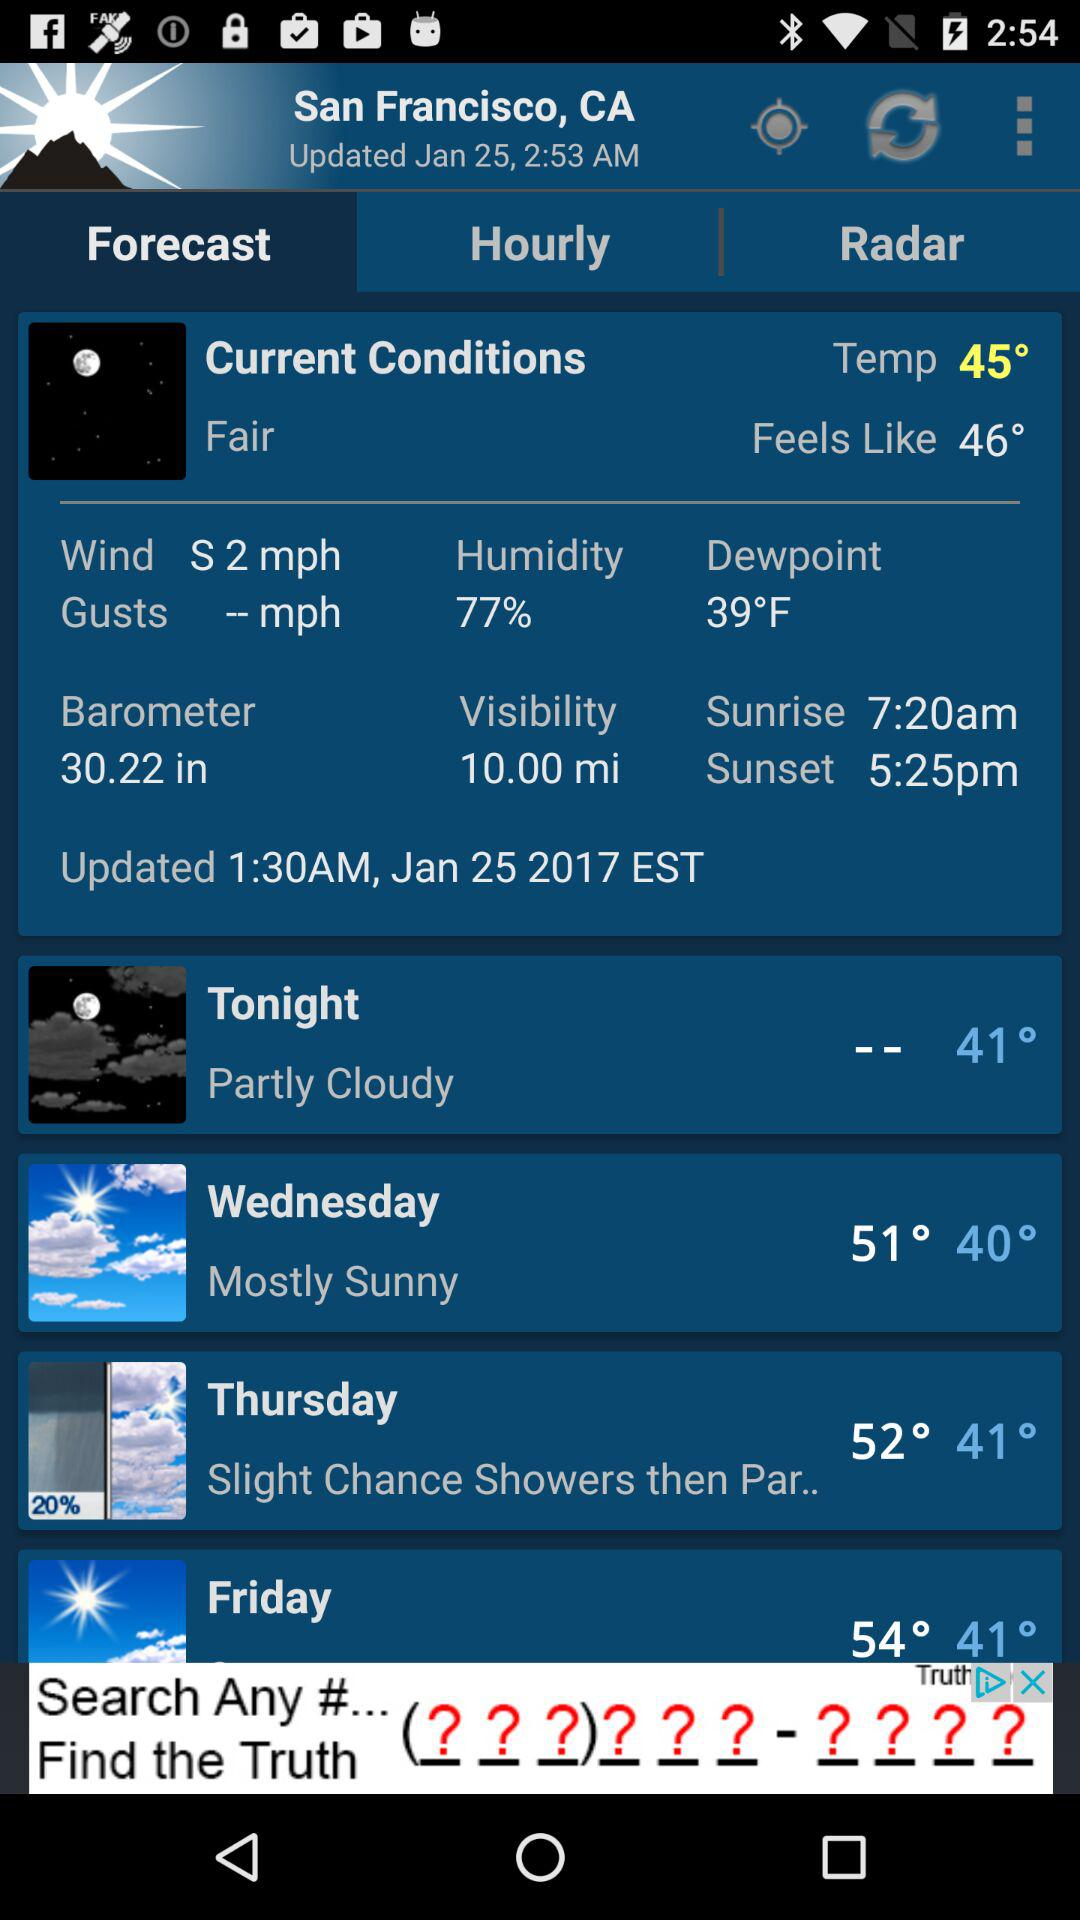What is the sunrise time in San Francisco? The sunrise time in San Francisco is 7:20 a.m. 